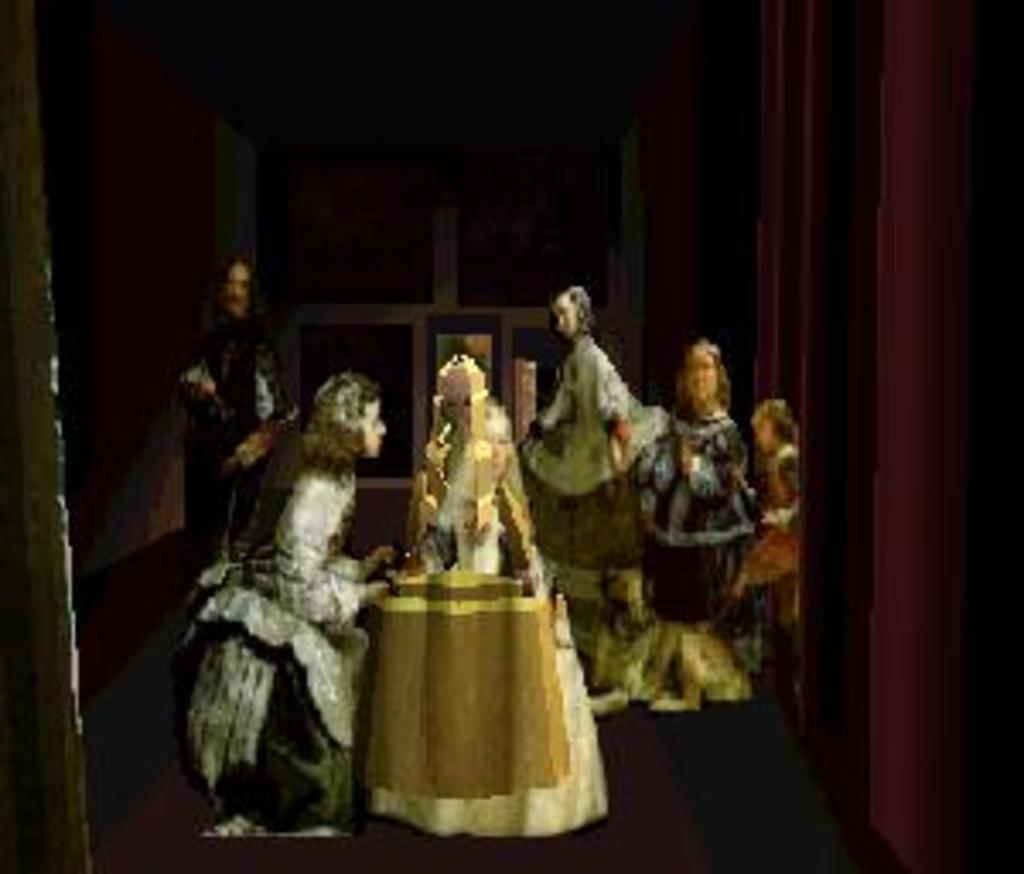How would you summarize this image in a sentence or two? This image consists of a frame. In which we can see the depiction of persons. At the bottom, there is a floor. The background is too dark. 